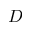<formula> <loc_0><loc_0><loc_500><loc_500>D</formula> 